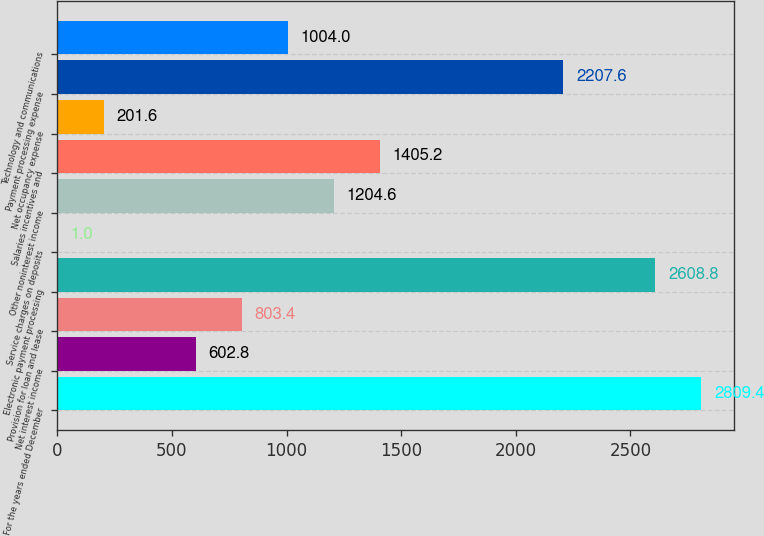<chart> <loc_0><loc_0><loc_500><loc_500><bar_chart><fcel>For the years ended December<fcel>Net interest income<fcel>Provision for loan and lease<fcel>Electronic payment processing<fcel>Service charges on deposits<fcel>Other noninterest income<fcel>Salaries incentives and<fcel>Net occupancy expense<fcel>Payment processing expense<fcel>Technology and communications<nl><fcel>2809.4<fcel>602.8<fcel>803.4<fcel>2608.8<fcel>1<fcel>1204.6<fcel>1405.2<fcel>201.6<fcel>2207.6<fcel>1004<nl></chart> 